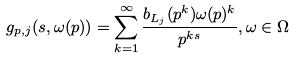<formula> <loc_0><loc_0><loc_500><loc_500>g _ { p , j } ( s , \omega ( p ) ) = \sum _ { k = 1 } ^ { \infty } \frac { b _ { L _ { j } } ( p ^ { k } ) \omega ( p ) ^ { k } } { p ^ { k s } } , \omega \in \Omega</formula> 